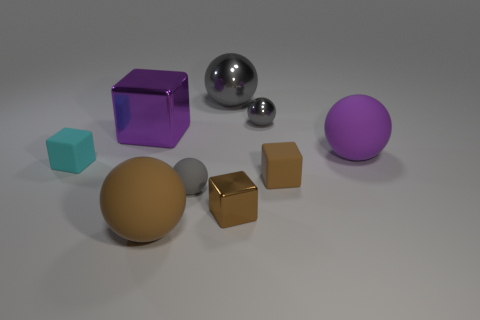How many brown blocks must be subtracted to get 1 brown blocks? 1 Subtract all purple spheres. How many spheres are left? 4 Subtract all green blocks. How many gray spheres are left? 3 Subtract all purple spheres. How many spheres are left? 4 Subtract all brown spheres. Subtract all purple cubes. How many spheres are left? 4 Add 1 small gray matte things. How many objects exist? 10 Subtract all blocks. How many objects are left? 5 Subtract all small green cylinders. Subtract all small balls. How many objects are left? 7 Add 9 purple matte objects. How many purple matte objects are left? 10 Add 2 tiny blue objects. How many tiny blue objects exist? 2 